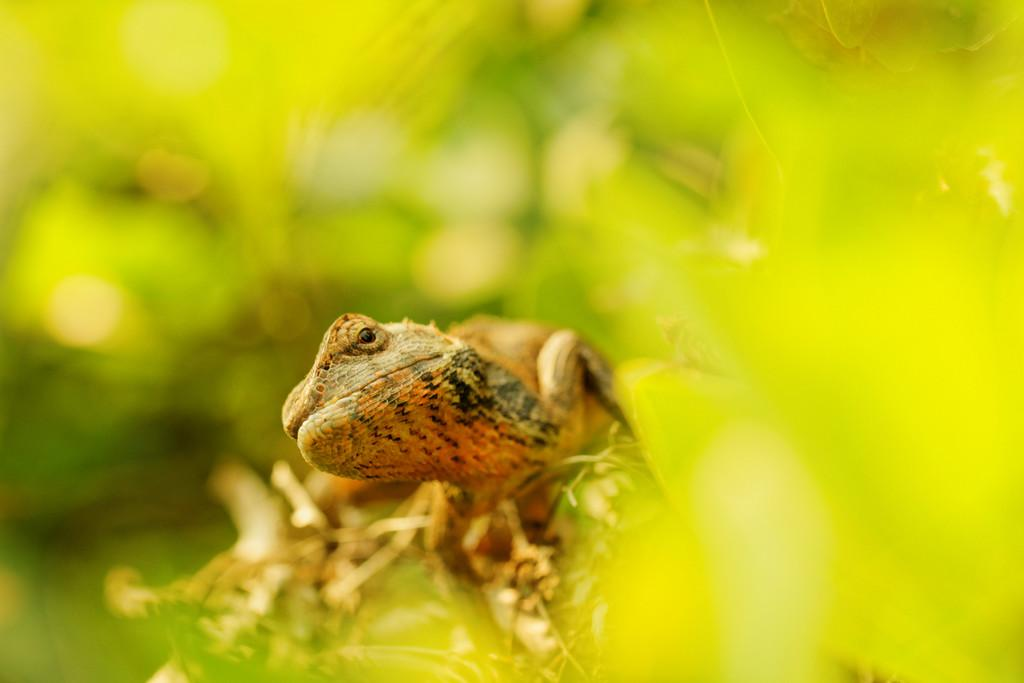What type of animal is in the image? There is a reptile in the image. Where is the reptile located? The reptile is on a plant. Can you describe the plant the reptile is on? The plant has leaves. What can be seen in the background of the image? There are other plants in the background of the image. What type of celery is growing on the reptile's chin in the image? There is no celery or chin present in the image; it features a reptile on a plant with leaves. 